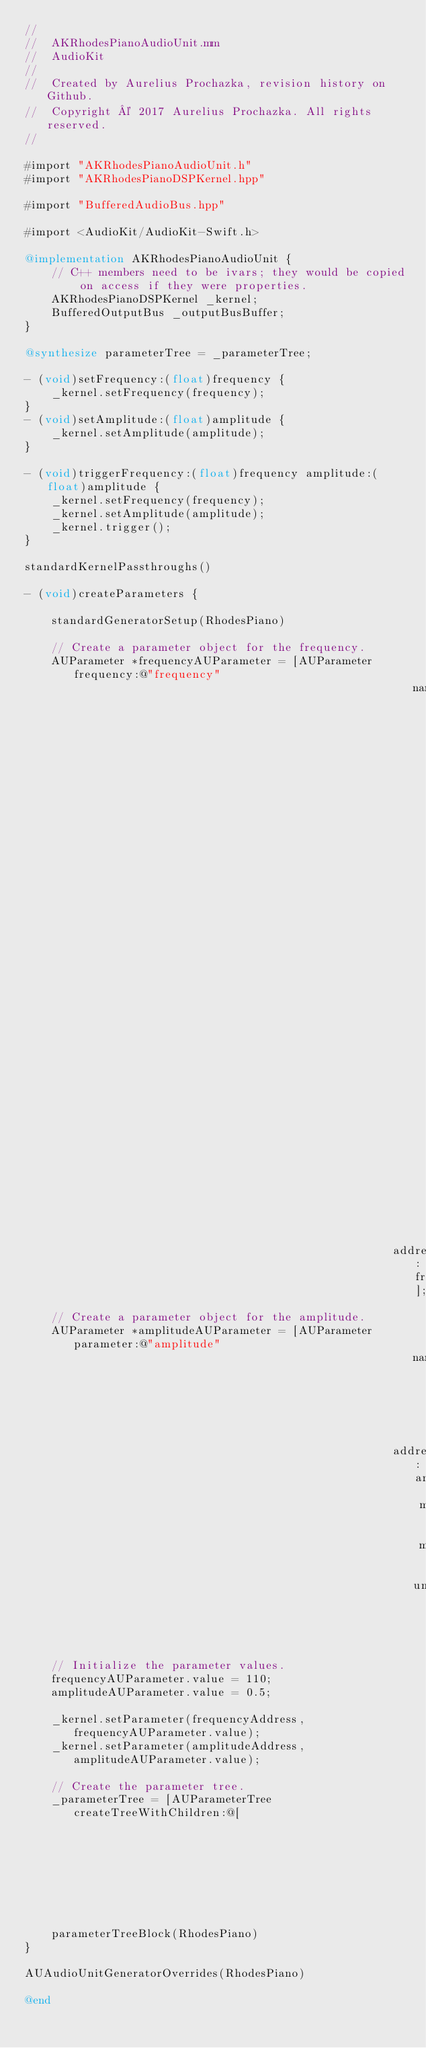<code> <loc_0><loc_0><loc_500><loc_500><_ObjectiveC_>//
//  AKRhodesPianoAudioUnit.mm
//  AudioKit
//
//  Created by Aurelius Prochazka, revision history on Github.
//  Copyright © 2017 Aurelius Prochazka. All rights reserved.
//

#import "AKRhodesPianoAudioUnit.h"
#import "AKRhodesPianoDSPKernel.hpp"

#import "BufferedAudioBus.hpp"

#import <AudioKit/AudioKit-Swift.h>

@implementation AKRhodesPianoAudioUnit {
    // C++ members need to be ivars; they would be copied on access if they were properties.
    AKRhodesPianoDSPKernel _kernel;
    BufferedOutputBus _outputBusBuffer;
}

@synthesize parameterTree = _parameterTree;

- (void)setFrequency:(float)frequency {
    _kernel.setFrequency(frequency);
}
- (void)setAmplitude:(float)amplitude {
    _kernel.setAmplitude(amplitude);
}

- (void)triggerFrequency:(float)frequency amplitude:(float)amplitude {
    _kernel.setFrequency(frequency);
    _kernel.setAmplitude(amplitude);
    _kernel.trigger();
}

standardKernelPassthroughs()

- (void)createParameters {
    
    standardGeneratorSetup(RhodesPiano)
    
    // Create a parameter object for the frequency.
    AUParameter *frequencyAUParameter = [AUParameter frequency:@"frequency"
                                                          name:@"Variable frequency. Values less than the initial frequency  will be doubled until it is greater than that."
                                                       address:frequencyAddress];
    // Create a parameter object for the amplitude.
    AUParameter *amplitudeAUParameter = [AUParameter parameter:@"amplitude"
                                                          name:@"Amplitude"
                                                       address:amplitudeAddress
                                                           min:0
                                                           max:1
                                                          unit:kAudioUnitParameterUnit_Generic];
    
    // Initialize the parameter values.
    frequencyAUParameter.value = 110;
    amplitudeAUParameter.value = 0.5;
    
    _kernel.setParameter(frequencyAddress,       frequencyAUParameter.value);
    _kernel.setParameter(amplitudeAddress,       amplitudeAUParameter.value);
    
    // Create the parameter tree.
    _parameterTree = [AUParameterTree createTreeWithChildren:@[
                                                               frequencyAUParameter,
                                                               amplitudeAUParameter
                                                               ]];
    
    parameterTreeBlock(RhodesPiano)
}

AUAudioUnitGeneratorOverrides(RhodesPiano)

@end


</code> 